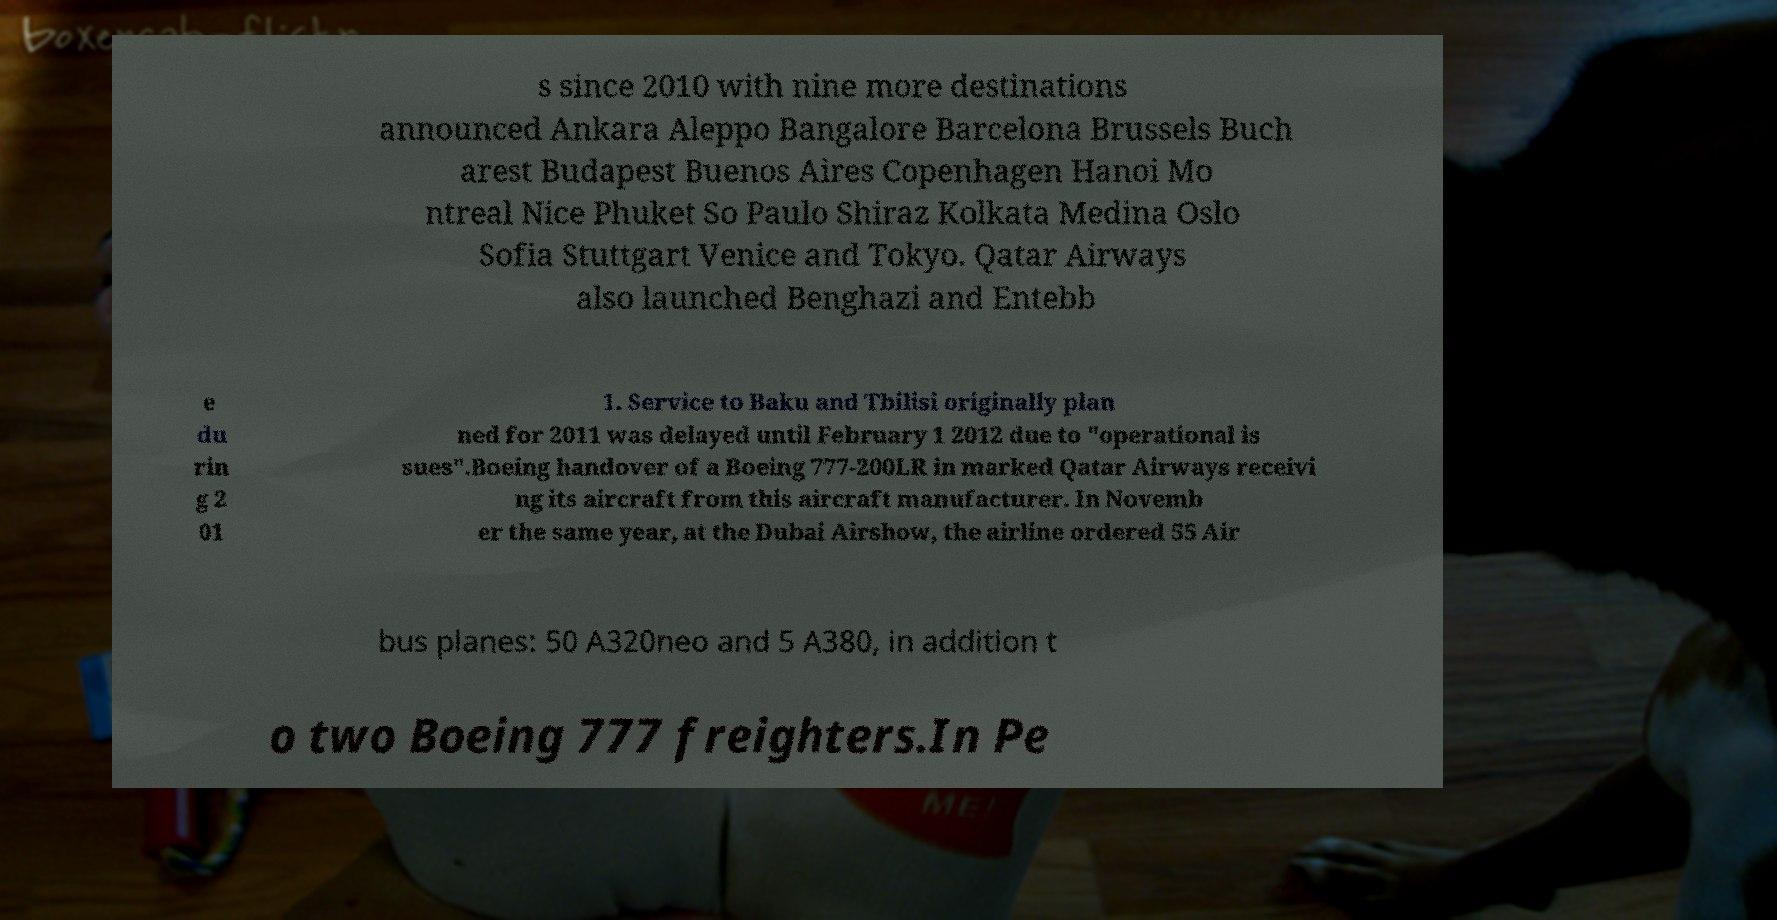I need the written content from this picture converted into text. Can you do that? s since 2010 with nine more destinations announced Ankara Aleppo Bangalore Barcelona Brussels Buch arest Budapest Buenos Aires Copenhagen Hanoi Mo ntreal Nice Phuket So Paulo Shiraz Kolkata Medina Oslo Sofia Stuttgart Venice and Tokyo. Qatar Airways also launched Benghazi and Entebb e du rin g 2 01 1. Service to Baku and Tbilisi originally plan ned for 2011 was delayed until February 1 2012 due to "operational is sues".Boeing handover of a Boeing 777-200LR in marked Qatar Airways receivi ng its aircraft from this aircraft manufacturer. In Novemb er the same year, at the Dubai Airshow, the airline ordered 55 Air bus planes: 50 A320neo and 5 A380, in addition t o two Boeing 777 freighters.In Pe 